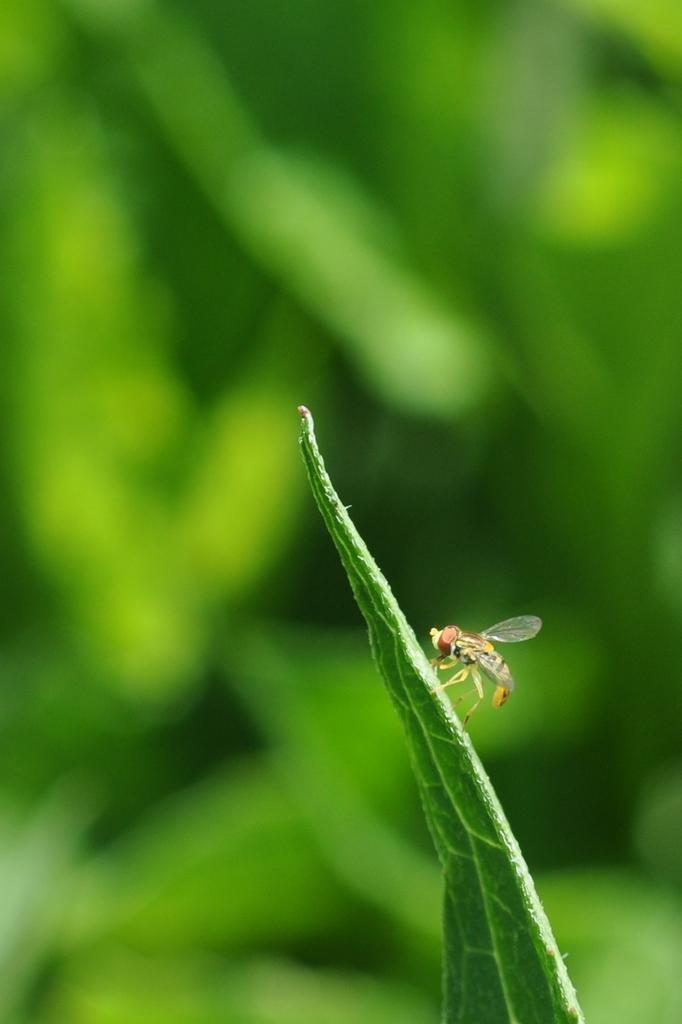Could you give a brief overview of what you see in this image? Background portion of the picture is blurry and its green color. In this picture we can see an insect on a green leaf. 